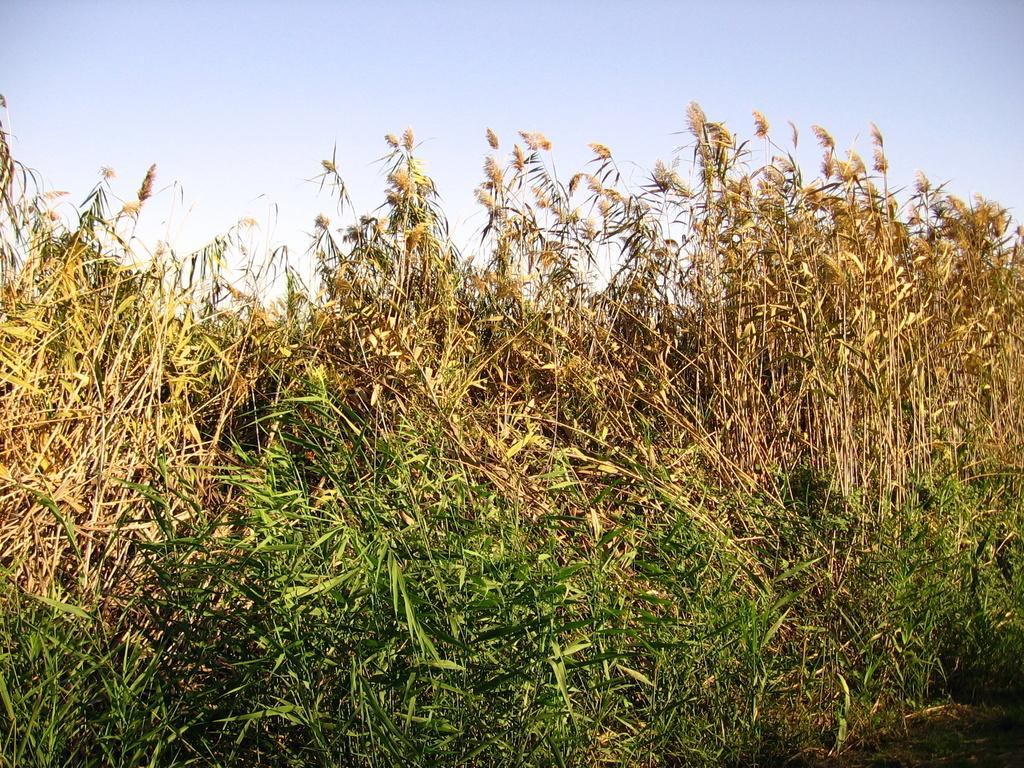What type of vegetation is present in the image? There are plants with leaves in the image. What part of the natural environment is visible in the image? The sky is visible in the image. Where is the bottle located in the image? There is no bottle present in the image. Can you describe the partner in the image? There is no partner present in the image. 